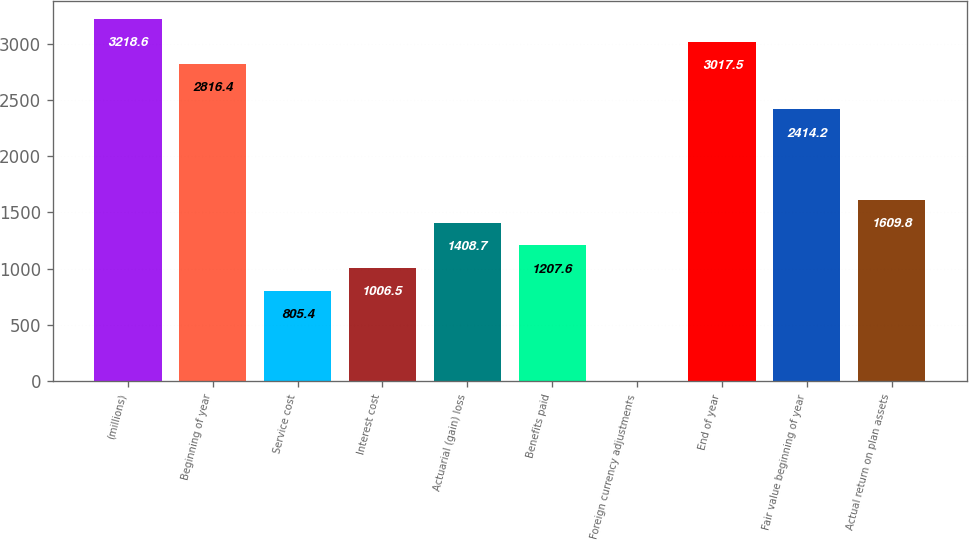<chart> <loc_0><loc_0><loc_500><loc_500><bar_chart><fcel>(millions)<fcel>Beginning of year<fcel>Service cost<fcel>Interest cost<fcel>Actuarial (gain) loss<fcel>Benefits paid<fcel>Foreign currency adjustments<fcel>End of year<fcel>Fair value beginning of year<fcel>Actual return on plan assets<nl><fcel>3218.6<fcel>2816.4<fcel>805.4<fcel>1006.5<fcel>1408.7<fcel>1207.6<fcel>1<fcel>3017.5<fcel>2414.2<fcel>1609.8<nl></chart> 